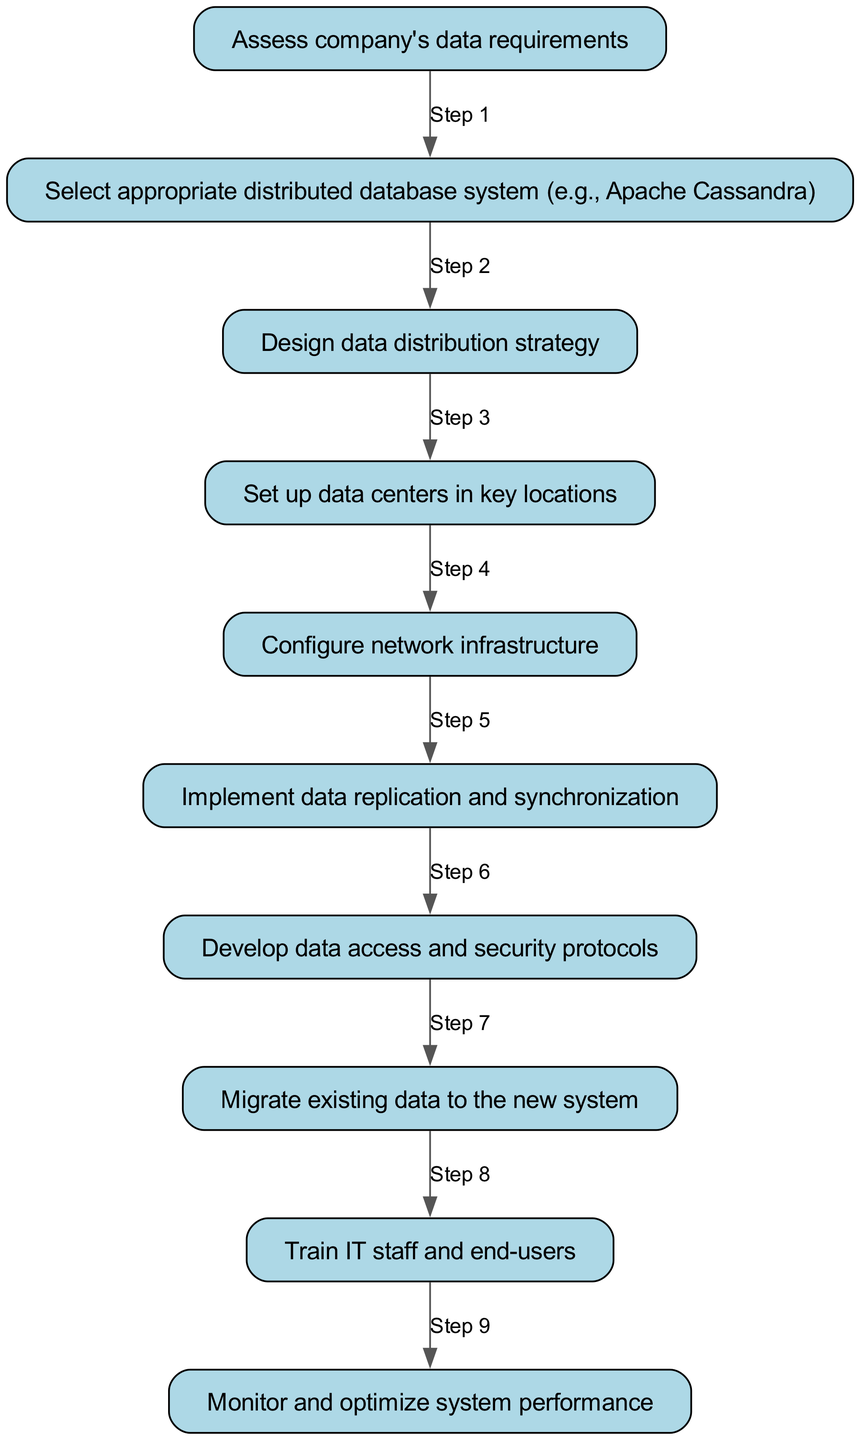What is the first step in the process? The first step in the flowchart is labeled as "Assess company's data requirements", which is represented as the first node in the diagram before any of the following steps.
Answer: Assess company's data requirements How many steps are involved in the process? The process has a total of ten steps, which can be counted by examining each individual node labeled in the flowchart.
Answer: Ten Which step involves selecting the database system? The step that involves selecting the database system is "Select appropriate distributed database system (e.g., Apache Cassandra)", which is indicated as the second node in the flowchart.
Answer: Select appropriate distributed database system (e.g., Apache Cassandra) What is the last step of the implementation process? The last step in the flowchart is "Monitor and optimize system performance", indicated as the final node in the sequence with no further steps following it.
Answer: Monitor and optimize system performance What is the primary focus of the sixth step? The sixth step focuses on "Implement data replication and synchronization", which is a critical phase in ensuring data consistency across the distributed system.
Answer: Implement data replication and synchronization Which step comes immediately after data migration? The step that follows "Migrate existing data to the new system" is "Train IT staff and end-users", making it the immediate subsequent action in the implementation process.
Answer: Train IT staff and end-users Explain the relationship between designing data distribution strategy and setting up data centers. The relationship is sequential; after "Design data distribution strategy", the next step is "Set up data centers in key locations". Thus, the strategy informs where the data centers should be located based on the design.
Answer: Sequential relationship What does the seventh step address regarding system security? The seventh step addresses "Develop data access and security protocols", highlighting the importance of establishing security measures for data access.
Answer: Develop data access and security protocols Which step is linked to network infrastructure? The step linked to network infrastructure is "Configure network infrastructure", which indicates the importance of network setup in relation to the database system implementation.
Answer: Configure network infrastructure 